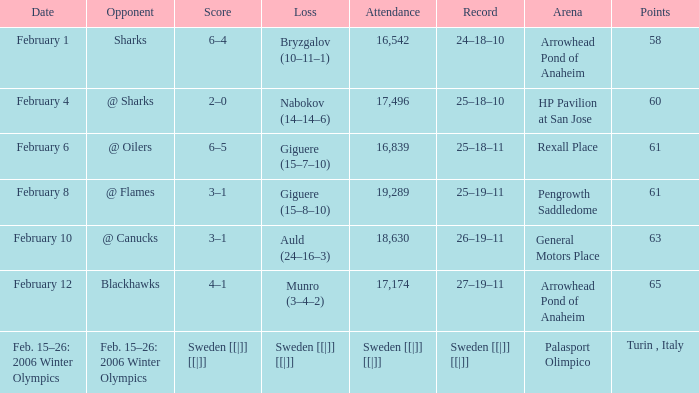What were the marks on february 10? 63.0. 